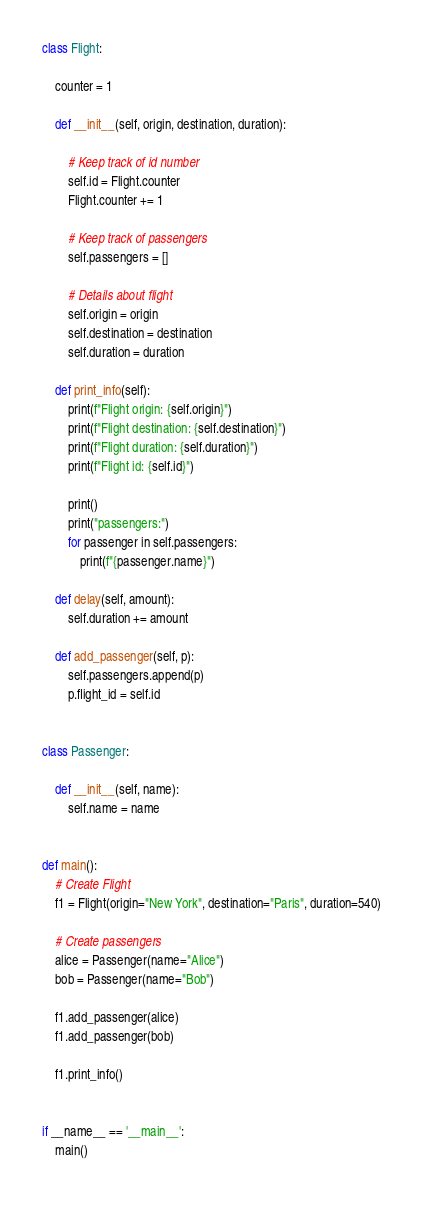<code> <loc_0><loc_0><loc_500><loc_500><_Python_>class Flight:

    counter = 1

    def __init__(self, origin, destination, duration):

        # Keep track of id number
        self.id = Flight.counter
        Flight.counter += 1

        # Keep track of passengers
        self.passengers = []

        # Details about flight
        self.origin = origin
        self.destination = destination
        self.duration = duration

    def print_info(self):
        print(f"Flight origin: {self.origin}")
        print(f"Flight destination: {self.destination}")
        print(f"Flight duration: {self.duration}")
        print(f"Flight id: {self.id}")

        print()
        print("passengers:")
        for passenger in self.passengers:
            print(f"{passenger.name}")

    def delay(self, amount):
        self.duration += amount

    def add_passenger(self, p):
        self.passengers.append(p)
        p.flight_id = self.id


class Passenger:

    def __init__(self, name):
        self.name = name


def main():
    # Create Flight
    f1 = Flight(origin="New York", destination="Paris", duration=540)

    # Create passengers
    alice = Passenger(name="Alice")
    bob = Passenger(name="Bob")

    f1.add_passenger(alice)
    f1.add_passenger(bob)

    f1.print_info()


if __name__ == '__main__':
    main()
</code> 